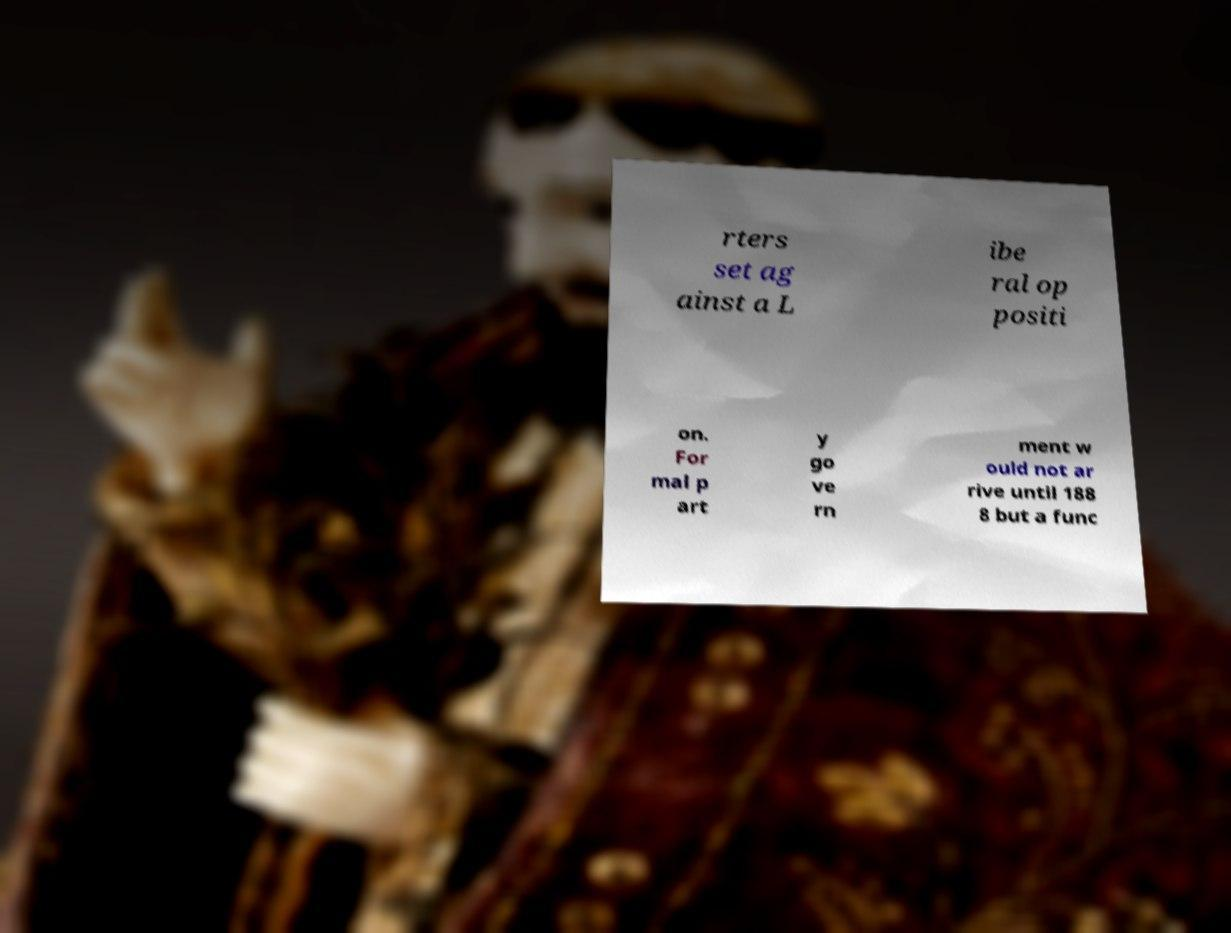Could you assist in decoding the text presented in this image and type it out clearly? rters set ag ainst a L ibe ral op positi on. For mal p art y go ve rn ment w ould not ar rive until 188 8 but a func 